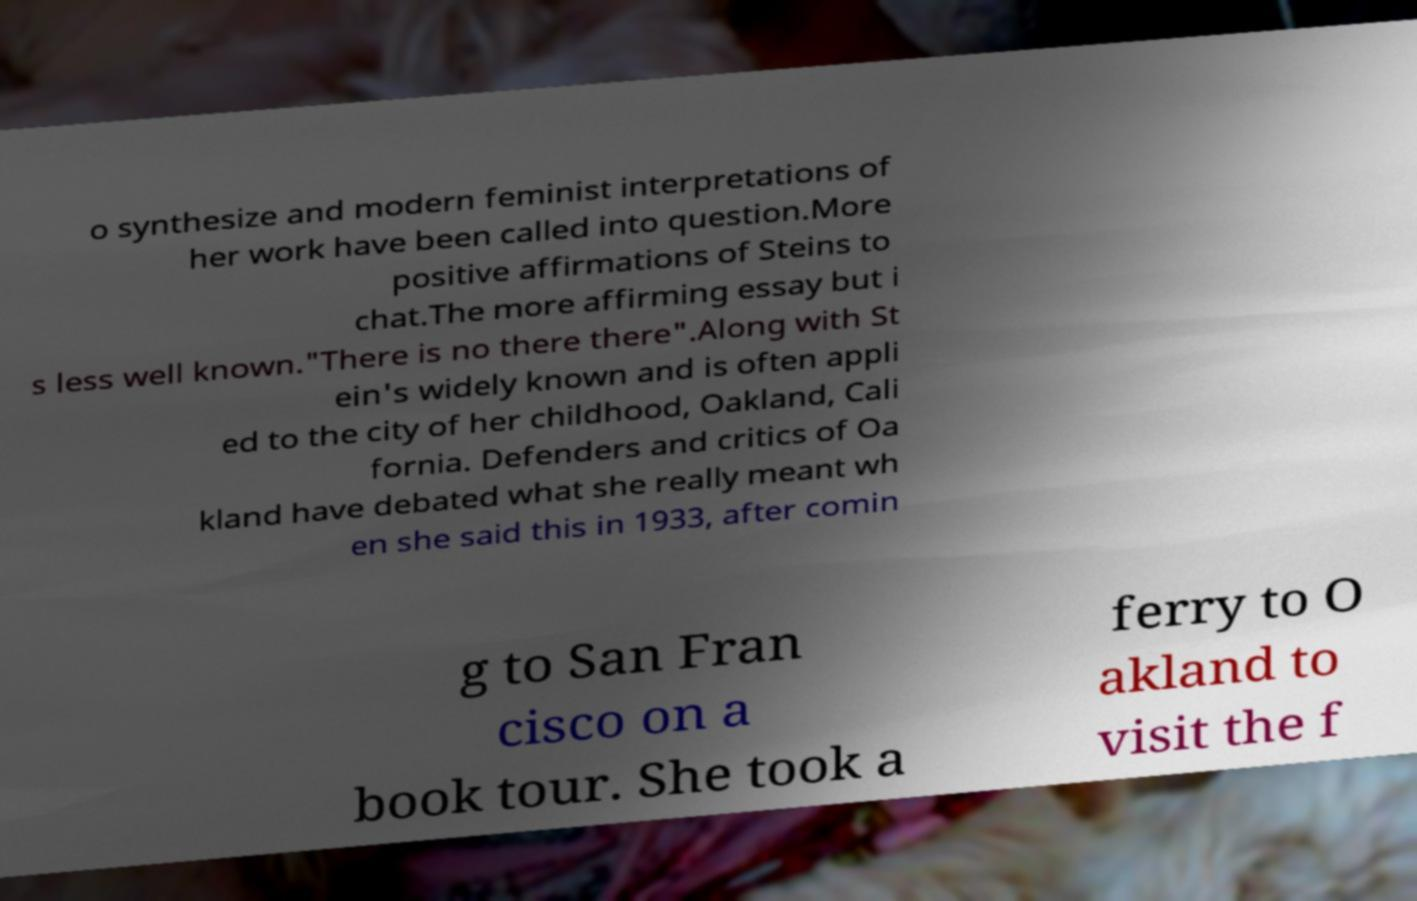What messages or text are displayed in this image? I need them in a readable, typed format. o synthesize and modern feminist interpretations of her work have been called into question.More positive affirmations of Steins to chat.The more affirming essay but i s less well known."There is no there there".Along with St ein's widely known and is often appli ed to the city of her childhood, Oakland, Cali fornia. Defenders and critics of Oa kland have debated what she really meant wh en she said this in 1933, after comin g to San Fran cisco on a book tour. She took a ferry to O akland to visit the f 